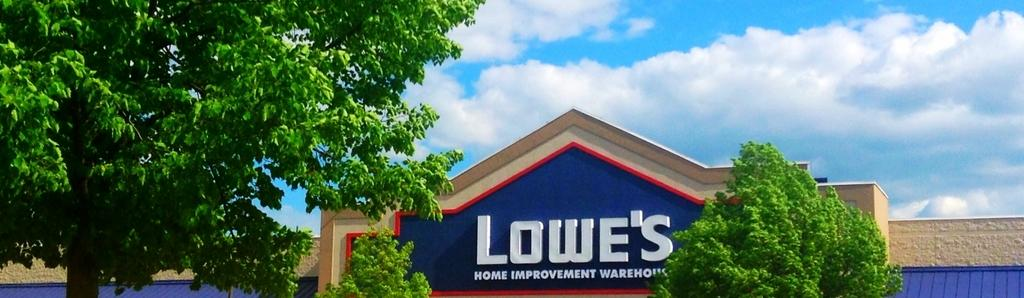What is the main structure in the image? There is a building with a name in the image. What type of vegetation can be seen in the image? There are trees in the image. What can be seen in the background of the image? The sky with clouds is visible in the background of the image. How does the chin help in the image? There is no chin present in the image, as it is a photograph of a building, trees, and the sky. 